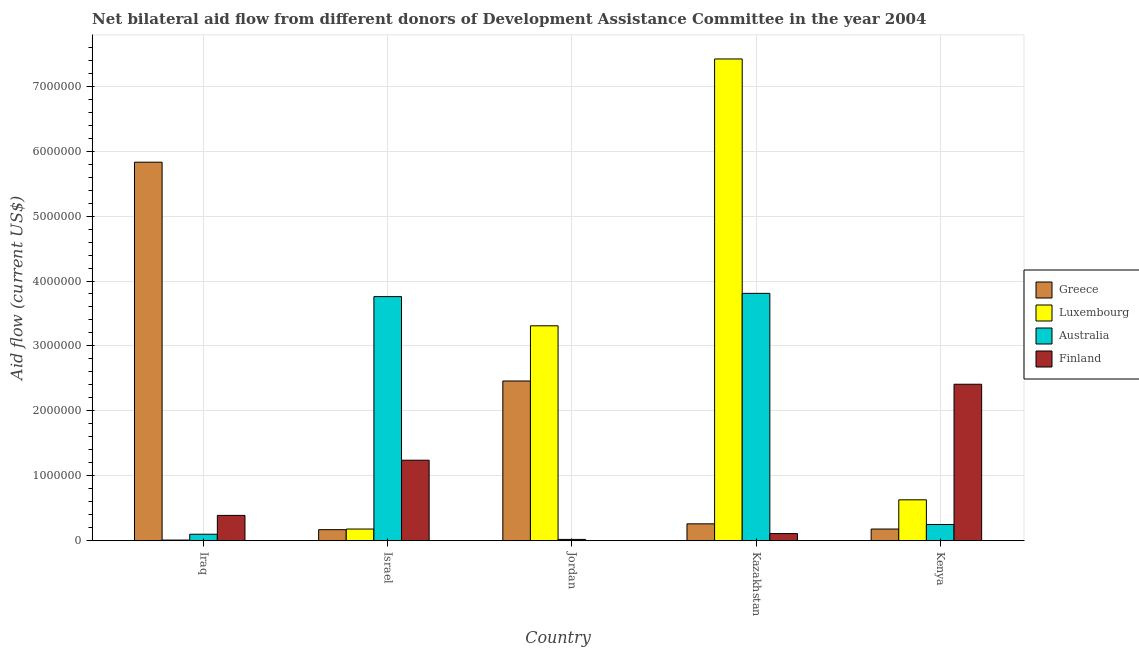How many different coloured bars are there?
Offer a terse response. 4. How many groups of bars are there?
Ensure brevity in your answer.  5. Are the number of bars per tick equal to the number of legend labels?
Your response must be concise. No. Are the number of bars on each tick of the X-axis equal?
Provide a succinct answer. No. What is the label of the 5th group of bars from the left?
Your answer should be compact. Kenya. In how many cases, is the number of bars for a given country not equal to the number of legend labels?
Your answer should be compact. 1. What is the amount of aid given by luxembourg in Kazakhstan?
Offer a terse response. 7.42e+06. Across all countries, what is the maximum amount of aid given by australia?
Offer a very short reply. 3.81e+06. Across all countries, what is the minimum amount of aid given by greece?
Provide a succinct answer. 1.70e+05. In which country was the amount of aid given by finland maximum?
Provide a short and direct response. Kenya. What is the total amount of aid given by greece in the graph?
Offer a very short reply. 8.90e+06. What is the difference between the amount of aid given by luxembourg in Israel and that in Kenya?
Make the answer very short. -4.50e+05. What is the difference between the amount of aid given by greece in Kenya and the amount of aid given by finland in Jordan?
Keep it short and to the point. 1.80e+05. What is the average amount of aid given by finland per country?
Give a very brief answer. 8.30e+05. What is the difference between the amount of aid given by finland and amount of aid given by greece in Israel?
Offer a very short reply. 1.07e+06. In how many countries, is the amount of aid given by finland greater than 7000000 US$?
Offer a very short reply. 0. What is the ratio of the amount of aid given by greece in Israel to that in Kazakhstan?
Your answer should be compact. 0.65. What is the difference between the highest and the second highest amount of aid given by luxembourg?
Your answer should be compact. 4.11e+06. What is the difference between the highest and the lowest amount of aid given by finland?
Your response must be concise. 2.41e+06. In how many countries, is the amount of aid given by greece greater than the average amount of aid given by greece taken over all countries?
Your answer should be compact. 2. Is it the case that in every country, the sum of the amount of aid given by greece and amount of aid given by australia is greater than the sum of amount of aid given by finland and amount of aid given by luxembourg?
Your answer should be compact. No. Is it the case that in every country, the sum of the amount of aid given by greece and amount of aid given by luxembourg is greater than the amount of aid given by australia?
Your response must be concise. No. How many bars are there?
Your answer should be compact. 19. What is the title of the graph?
Offer a terse response. Net bilateral aid flow from different donors of Development Assistance Committee in the year 2004. What is the label or title of the X-axis?
Provide a succinct answer. Country. What is the Aid flow (current US$) in Greece in Iraq?
Provide a succinct answer. 5.83e+06. What is the Aid flow (current US$) of Luxembourg in Iraq?
Offer a terse response. 10000. What is the Aid flow (current US$) of Australia in Iraq?
Your answer should be very brief. 1.00e+05. What is the Aid flow (current US$) in Greece in Israel?
Ensure brevity in your answer.  1.70e+05. What is the Aid flow (current US$) in Australia in Israel?
Your answer should be very brief. 3.76e+06. What is the Aid flow (current US$) of Finland in Israel?
Provide a short and direct response. 1.24e+06. What is the Aid flow (current US$) in Greece in Jordan?
Provide a short and direct response. 2.46e+06. What is the Aid flow (current US$) in Luxembourg in Jordan?
Make the answer very short. 3.31e+06. What is the Aid flow (current US$) of Australia in Jordan?
Keep it short and to the point. 2.00e+04. What is the Aid flow (current US$) in Luxembourg in Kazakhstan?
Offer a terse response. 7.42e+06. What is the Aid flow (current US$) of Australia in Kazakhstan?
Your answer should be very brief. 3.81e+06. What is the Aid flow (current US$) in Greece in Kenya?
Provide a succinct answer. 1.80e+05. What is the Aid flow (current US$) of Luxembourg in Kenya?
Provide a succinct answer. 6.30e+05. What is the Aid flow (current US$) in Australia in Kenya?
Make the answer very short. 2.50e+05. What is the Aid flow (current US$) in Finland in Kenya?
Your answer should be very brief. 2.41e+06. Across all countries, what is the maximum Aid flow (current US$) in Greece?
Your response must be concise. 5.83e+06. Across all countries, what is the maximum Aid flow (current US$) of Luxembourg?
Offer a very short reply. 7.42e+06. Across all countries, what is the maximum Aid flow (current US$) of Australia?
Provide a succinct answer. 3.81e+06. Across all countries, what is the maximum Aid flow (current US$) of Finland?
Your response must be concise. 2.41e+06. Across all countries, what is the minimum Aid flow (current US$) in Greece?
Your answer should be compact. 1.70e+05. Across all countries, what is the minimum Aid flow (current US$) in Luxembourg?
Provide a succinct answer. 10000. Across all countries, what is the minimum Aid flow (current US$) in Australia?
Offer a terse response. 2.00e+04. Across all countries, what is the minimum Aid flow (current US$) in Finland?
Provide a short and direct response. 0. What is the total Aid flow (current US$) of Greece in the graph?
Provide a short and direct response. 8.90e+06. What is the total Aid flow (current US$) in Luxembourg in the graph?
Your response must be concise. 1.16e+07. What is the total Aid flow (current US$) in Australia in the graph?
Offer a very short reply. 7.94e+06. What is the total Aid flow (current US$) in Finland in the graph?
Offer a terse response. 4.15e+06. What is the difference between the Aid flow (current US$) of Greece in Iraq and that in Israel?
Your answer should be compact. 5.66e+06. What is the difference between the Aid flow (current US$) in Australia in Iraq and that in Israel?
Provide a short and direct response. -3.66e+06. What is the difference between the Aid flow (current US$) of Finland in Iraq and that in Israel?
Give a very brief answer. -8.50e+05. What is the difference between the Aid flow (current US$) in Greece in Iraq and that in Jordan?
Keep it short and to the point. 3.37e+06. What is the difference between the Aid flow (current US$) of Luxembourg in Iraq and that in Jordan?
Give a very brief answer. -3.30e+06. What is the difference between the Aid flow (current US$) of Australia in Iraq and that in Jordan?
Offer a terse response. 8.00e+04. What is the difference between the Aid flow (current US$) in Greece in Iraq and that in Kazakhstan?
Your answer should be compact. 5.57e+06. What is the difference between the Aid flow (current US$) in Luxembourg in Iraq and that in Kazakhstan?
Your response must be concise. -7.41e+06. What is the difference between the Aid flow (current US$) of Australia in Iraq and that in Kazakhstan?
Offer a terse response. -3.71e+06. What is the difference between the Aid flow (current US$) of Finland in Iraq and that in Kazakhstan?
Provide a succinct answer. 2.80e+05. What is the difference between the Aid flow (current US$) in Greece in Iraq and that in Kenya?
Provide a short and direct response. 5.65e+06. What is the difference between the Aid flow (current US$) of Luxembourg in Iraq and that in Kenya?
Offer a very short reply. -6.20e+05. What is the difference between the Aid flow (current US$) in Finland in Iraq and that in Kenya?
Provide a succinct answer. -2.02e+06. What is the difference between the Aid flow (current US$) of Greece in Israel and that in Jordan?
Your response must be concise. -2.29e+06. What is the difference between the Aid flow (current US$) of Luxembourg in Israel and that in Jordan?
Make the answer very short. -3.13e+06. What is the difference between the Aid flow (current US$) of Australia in Israel and that in Jordan?
Make the answer very short. 3.74e+06. What is the difference between the Aid flow (current US$) of Greece in Israel and that in Kazakhstan?
Keep it short and to the point. -9.00e+04. What is the difference between the Aid flow (current US$) in Luxembourg in Israel and that in Kazakhstan?
Your answer should be very brief. -7.24e+06. What is the difference between the Aid flow (current US$) in Australia in Israel and that in Kazakhstan?
Keep it short and to the point. -5.00e+04. What is the difference between the Aid flow (current US$) of Finland in Israel and that in Kazakhstan?
Give a very brief answer. 1.13e+06. What is the difference between the Aid flow (current US$) in Luxembourg in Israel and that in Kenya?
Make the answer very short. -4.50e+05. What is the difference between the Aid flow (current US$) in Australia in Israel and that in Kenya?
Your answer should be compact. 3.51e+06. What is the difference between the Aid flow (current US$) in Finland in Israel and that in Kenya?
Provide a succinct answer. -1.17e+06. What is the difference between the Aid flow (current US$) of Greece in Jordan and that in Kazakhstan?
Your answer should be very brief. 2.20e+06. What is the difference between the Aid flow (current US$) of Luxembourg in Jordan and that in Kazakhstan?
Make the answer very short. -4.11e+06. What is the difference between the Aid flow (current US$) in Australia in Jordan and that in Kazakhstan?
Your answer should be compact. -3.79e+06. What is the difference between the Aid flow (current US$) of Greece in Jordan and that in Kenya?
Your response must be concise. 2.28e+06. What is the difference between the Aid flow (current US$) in Luxembourg in Jordan and that in Kenya?
Provide a short and direct response. 2.68e+06. What is the difference between the Aid flow (current US$) of Luxembourg in Kazakhstan and that in Kenya?
Provide a short and direct response. 6.79e+06. What is the difference between the Aid flow (current US$) in Australia in Kazakhstan and that in Kenya?
Keep it short and to the point. 3.56e+06. What is the difference between the Aid flow (current US$) of Finland in Kazakhstan and that in Kenya?
Provide a short and direct response. -2.30e+06. What is the difference between the Aid flow (current US$) of Greece in Iraq and the Aid flow (current US$) of Luxembourg in Israel?
Offer a terse response. 5.65e+06. What is the difference between the Aid flow (current US$) of Greece in Iraq and the Aid flow (current US$) of Australia in Israel?
Keep it short and to the point. 2.07e+06. What is the difference between the Aid flow (current US$) of Greece in Iraq and the Aid flow (current US$) of Finland in Israel?
Your response must be concise. 4.59e+06. What is the difference between the Aid flow (current US$) of Luxembourg in Iraq and the Aid flow (current US$) of Australia in Israel?
Ensure brevity in your answer.  -3.75e+06. What is the difference between the Aid flow (current US$) in Luxembourg in Iraq and the Aid flow (current US$) in Finland in Israel?
Make the answer very short. -1.23e+06. What is the difference between the Aid flow (current US$) in Australia in Iraq and the Aid flow (current US$) in Finland in Israel?
Your answer should be compact. -1.14e+06. What is the difference between the Aid flow (current US$) of Greece in Iraq and the Aid flow (current US$) of Luxembourg in Jordan?
Offer a terse response. 2.52e+06. What is the difference between the Aid flow (current US$) of Greece in Iraq and the Aid flow (current US$) of Australia in Jordan?
Your response must be concise. 5.81e+06. What is the difference between the Aid flow (current US$) in Greece in Iraq and the Aid flow (current US$) in Luxembourg in Kazakhstan?
Your answer should be very brief. -1.59e+06. What is the difference between the Aid flow (current US$) of Greece in Iraq and the Aid flow (current US$) of Australia in Kazakhstan?
Ensure brevity in your answer.  2.02e+06. What is the difference between the Aid flow (current US$) in Greece in Iraq and the Aid flow (current US$) in Finland in Kazakhstan?
Make the answer very short. 5.72e+06. What is the difference between the Aid flow (current US$) in Luxembourg in Iraq and the Aid flow (current US$) in Australia in Kazakhstan?
Offer a terse response. -3.80e+06. What is the difference between the Aid flow (current US$) in Luxembourg in Iraq and the Aid flow (current US$) in Finland in Kazakhstan?
Your answer should be very brief. -1.00e+05. What is the difference between the Aid flow (current US$) in Greece in Iraq and the Aid flow (current US$) in Luxembourg in Kenya?
Provide a succinct answer. 5.20e+06. What is the difference between the Aid flow (current US$) in Greece in Iraq and the Aid flow (current US$) in Australia in Kenya?
Offer a very short reply. 5.58e+06. What is the difference between the Aid flow (current US$) of Greece in Iraq and the Aid flow (current US$) of Finland in Kenya?
Give a very brief answer. 3.42e+06. What is the difference between the Aid flow (current US$) in Luxembourg in Iraq and the Aid flow (current US$) in Finland in Kenya?
Your response must be concise. -2.40e+06. What is the difference between the Aid flow (current US$) of Australia in Iraq and the Aid flow (current US$) of Finland in Kenya?
Keep it short and to the point. -2.31e+06. What is the difference between the Aid flow (current US$) of Greece in Israel and the Aid flow (current US$) of Luxembourg in Jordan?
Give a very brief answer. -3.14e+06. What is the difference between the Aid flow (current US$) in Luxembourg in Israel and the Aid flow (current US$) in Australia in Jordan?
Your answer should be compact. 1.60e+05. What is the difference between the Aid flow (current US$) in Greece in Israel and the Aid flow (current US$) in Luxembourg in Kazakhstan?
Keep it short and to the point. -7.25e+06. What is the difference between the Aid flow (current US$) in Greece in Israel and the Aid flow (current US$) in Australia in Kazakhstan?
Your answer should be very brief. -3.64e+06. What is the difference between the Aid flow (current US$) of Luxembourg in Israel and the Aid flow (current US$) of Australia in Kazakhstan?
Offer a terse response. -3.63e+06. What is the difference between the Aid flow (current US$) of Luxembourg in Israel and the Aid flow (current US$) of Finland in Kazakhstan?
Your answer should be very brief. 7.00e+04. What is the difference between the Aid flow (current US$) in Australia in Israel and the Aid flow (current US$) in Finland in Kazakhstan?
Ensure brevity in your answer.  3.65e+06. What is the difference between the Aid flow (current US$) of Greece in Israel and the Aid flow (current US$) of Luxembourg in Kenya?
Ensure brevity in your answer.  -4.60e+05. What is the difference between the Aid flow (current US$) in Greece in Israel and the Aid flow (current US$) in Australia in Kenya?
Make the answer very short. -8.00e+04. What is the difference between the Aid flow (current US$) of Greece in Israel and the Aid flow (current US$) of Finland in Kenya?
Make the answer very short. -2.24e+06. What is the difference between the Aid flow (current US$) of Luxembourg in Israel and the Aid flow (current US$) of Australia in Kenya?
Ensure brevity in your answer.  -7.00e+04. What is the difference between the Aid flow (current US$) in Luxembourg in Israel and the Aid flow (current US$) in Finland in Kenya?
Offer a very short reply. -2.23e+06. What is the difference between the Aid flow (current US$) in Australia in Israel and the Aid flow (current US$) in Finland in Kenya?
Your response must be concise. 1.35e+06. What is the difference between the Aid flow (current US$) of Greece in Jordan and the Aid flow (current US$) of Luxembourg in Kazakhstan?
Offer a very short reply. -4.96e+06. What is the difference between the Aid flow (current US$) of Greece in Jordan and the Aid flow (current US$) of Australia in Kazakhstan?
Offer a very short reply. -1.35e+06. What is the difference between the Aid flow (current US$) in Greece in Jordan and the Aid flow (current US$) in Finland in Kazakhstan?
Provide a short and direct response. 2.35e+06. What is the difference between the Aid flow (current US$) in Luxembourg in Jordan and the Aid flow (current US$) in Australia in Kazakhstan?
Offer a terse response. -5.00e+05. What is the difference between the Aid flow (current US$) in Luxembourg in Jordan and the Aid flow (current US$) in Finland in Kazakhstan?
Give a very brief answer. 3.20e+06. What is the difference between the Aid flow (current US$) of Greece in Jordan and the Aid flow (current US$) of Luxembourg in Kenya?
Your answer should be very brief. 1.83e+06. What is the difference between the Aid flow (current US$) of Greece in Jordan and the Aid flow (current US$) of Australia in Kenya?
Ensure brevity in your answer.  2.21e+06. What is the difference between the Aid flow (current US$) of Greece in Jordan and the Aid flow (current US$) of Finland in Kenya?
Offer a very short reply. 5.00e+04. What is the difference between the Aid flow (current US$) in Luxembourg in Jordan and the Aid flow (current US$) in Australia in Kenya?
Offer a terse response. 3.06e+06. What is the difference between the Aid flow (current US$) of Australia in Jordan and the Aid flow (current US$) of Finland in Kenya?
Your answer should be very brief. -2.39e+06. What is the difference between the Aid flow (current US$) in Greece in Kazakhstan and the Aid flow (current US$) in Luxembourg in Kenya?
Your response must be concise. -3.70e+05. What is the difference between the Aid flow (current US$) in Greece in Kazakhstan and the Aid flow (current US$) in Finland in Kenya?
Your answer should be compact. -2.15e+06. What is the difference between the Aid flow (current US$) of Luxembourg in Kazakhstan and the Aid flow (current US$) of Australia in Kenya?
Your answer should be compact. 7.17e+06. What is the difference between the Aid flow (current US$) of Luxembourg in Kazakhstan and the Aid flow (current US$) of Finland in Kenya?
Offer a very short reply. 5.01e+06. What is the difference between the Aid flow (current US$) of Australia in Kazakhstan and the Aid flow (current US$) of Finland in Kenya?
Give a very brief answer. 1.40e+06. What is the average Aid flow (current US$) of Greece per country?
Your answer should be very brief. 1.78e+06. What is the average Aid flow (current US$) of Luxembourg per country?
Offer a very short reply. 2.31e+06. What is the average Aid flow (current US$) in Australia per country?
Offer a very short reply. 1.59e+06. What is the average Aid flow (current US$) of Finland per country?
Provide a succinct answer. 8.30e+05. What is the difference between the Aid flow (current US$) of Greece and Aid flow (current US$) of Luxembourg in Iraq?
Provide a short and direct response. 5.82e+06. What is the difference between the Aid flow (current US$) in Greece and Aid flow (current US$) in Australia in Iraq?
Your answer should be compact. 5.73e+06. What is the difference between the Aid flow (current US$) of Greece and Aid flow (current US$) of Finland in Iraq?
Give a very brief answer. 5.44e+06. What is the difference between the Aid flow (current US$) in Luxembourg and Aid flow (current US$) in Australia in Iraq?
Your answer should be very brief. -9.00e+04. What is the difference between the Aid flow (current US$) in Luxembourg and Aid flow (current US$) in Finland in Iraq?
Your response must be concise. -3.80e+05. What is the difference between the Aid flow (current US$) of Australia and Aid flow (current US$) of Finland in Iraq?
Ensure brevity in your answer.  -2.90e+05. What is the difference between the Aid flow (current US$) of Greece and Aid flow (current US$) of Australia in Israel?
Provide a succinct answer. -3.59e+06. What is the difference between the Aid flow (current US$) in Greece and Aid flow (current US$) in Finland in Israel?
Your response must be concise. -1.07e+06. What is the difference between the Aid flow (current US$) of Luxembourg and Aid flow (current US$) of Australia in Israel?
Ensure brevity in your answer.  -3.58e+06. What is the difference between the Aid flow (current US$) of Luxembourg and Aid flow (current US$) of Finland in Israel?
Give a very brief answer. -1.06e+06. What is the difference between the Aid flow (current US$) in Australia and Aid flow (current US$) in Finland in Israel?
Make the answer very short. 2.52e+06. What is the difference between the Aid flow (current US$) of Greece and Aid flow (current US$) of Luxembourg in Jordan?
Your response must be concise. -8.50e+05. What is the difference between the Aid flow (current US$) in Greece and Aid flow (current US$) in Australia in Jordan?
Make the answer very short. 2.44e+06. What is the difference between the Aid flow (current US$) of Luxembourg and Aid flow (current US$) of Australia in Jordan?
Give a very brief answer. 3.29e+06. What is the difference between the Aid flow (current US$) in Greece and Aid flow (current US$) in Luxembourg in Kazakhstan?
Your answer should be very brief. -7.16e+06. What is the difference between the Aid flow (current US$) in Greece and Aid flow (current US$) in Australia in Kazakhstan?
Provide a short and direct response. -3.55e+06. What is the difference between the Aid flow (current US$) of Greece and Aid flow (current US$) of Finland in Kazakhstan?
Give a very brief answer. 1.50e+05. What is the difference between the Aid flow (current US$) in Luxembourg and Aid flow (current US$) in Australia in Kazakhstan?
Provide a short and direct response. 3.61e+06. What is the difference between the Aid flow (current US$) of Luxembourg and Aid flow (current US$) of Finland in Kazakhstan?
Provide a succinct answer. 7.31e+06. What is the difference between the Aid flow (current US$) of Australia and Aid flow (current US$) of Finland in Kazakhstan?
Give a very brief answer. 3.70e+06. What is the difference between the Aid flow (current US$) in Greece and Aid flow (current US$) in Luxembourg in Kenya?
Provide a succinct answer. -4.50e+05. What is the difference between the Aid flow (current US$) in Greece and Aid flow (current US$) in Finland in Kenya?
Your response must be concise. -2.23e+06. What is the difference between the Aid flow (current US$) of Luxembourg and Aid flow (current US$) of Australia in Kenya?
Your answer should be very brief. 3.80e+05. What is the difference between the Aid flow (current US$) of Luxembourg and Aid flow (current US$) of Finland in Kenya?
Provide a short and direct response. -1.78e+06. What is the difference between the Aid flow (current US$) of Australia and Aid flow (current US$) of Finland in Kenya?
Provide a short and direct response. -2.16e+06. What is the ratio of the Aid flow (current US$) of Greece in Iraq to that in Israel?
Your answer should be very brief. 34.29. What is the ratio of the Aid flow (current US$) in Luxembourg in Iraq to that in Israel?
Offer a very short reply. 0.06. What is the ratio of the Aid flow (current US$) in Australia in Iraq to that in Israel?
Offer a terse response. 0.03. What is the ratio of the Aid flow (current US$) of Finland in Iraq to that in Israel?
Offer a terse response. 0.31. What is the ratio of the Aid flow (current US$) in Greece in Iraq to that in Jordan?
Give a very brief answer. 2.37. What is the ratio of the Aid flow (current US$) of Luxembourg in Iraq to that in Jordan?
Make the answer very short. 0. What is the ratio of the Aid flow (current US$) in Greece in Iraq to that in Kazakhstan?
Ensure brevity in your answer.  22.42. What is the ratio of the Aid flow (current US$) in Luxembourg in Iraq to that in Kazakhstan?
Your answer should be very brief. 0. What is the ratio of the Aid flow (current US$) of Australia in Iraq to that in Kazakhstan?
Your answer should be compact. 0.03. What is the ratio of the Aid flow (current US$) in Finland in Iraq to that in Kazakhstan?
Ensure brevity in your answer.  3.55. What is the ratio of the Aid flow (current US$) of Greece in Iraq to that in Kenya?
Ensure brevity in your answer.  32.39. What is the ratio of the Aid flow (current US$) of Luxembourg in Iraq to that in Kenya?
Your answer should be very brief. 0.02. What is the ratio of the Aid flow (current US$) of Finland in Iraq to that in Kenya?
Offer a very short reply. 0.16. What is the ratio of the Aid flow (current US$) in Greece in Israel to that in Jordan?
Make the answer very short. 0.07. What is the ratio of the Aid flow (current US$) in Luxembourg in Israel to that in Jordan?
Your response must be concise. 0.05. What is the ratio of the Aid flow (current US$) in Australia in Israel to that in Jordan?
Keep it short and to the point. 188. What is the ratio of the Aid flow (current US$) in Greece in Israel to that in Kazakhstan?
Provide a succinct answer. 0.65. What is the ratio of the Aid flow (current US$) in Luxembourg in Israel to that in Kazakhstan?
Ensure brevity in your answer.  0.02. What is the ratio of the Aid flow (current US$) in Australia in Israel to that in Kazakhstan?
Offer a very short reply. 0.99. What is the ratio of the Aid flow (current US$) of Finland in Israel to that in Kazakhstan?
Your response must be concise. 11.27. What is the ratio of the Aid flow (current US$) of Greece in Israel to that in Kenya?
Your answer should be very brief. 0.94. What is the ratio of the Aid flow (current US$) in Luxembourg in Israel to that in Kenya?
Offer a very short reply. 0.29. What is the ratio of the Aid flow (current US$) of Australia in Israel to that in Kenya?
Keep it short and to the point. 15.04. What is the ratio of the Aid flow (current US$) in Finland in Israel to that in Kenya?
Provide a succinct answer. 0.51. What is the ratio of the Aid flow (current US$) of Greece in Jordan to that in Kazakhstan?
Provide a succinct answer. 9.46. What is the ratio of the Aid flow (current US$) in Luxembourg in Jordan to that in Kazakhstan?
Give a very brief answer. 0.45. What is the ratio of the Aid flow (current US$) in Australia in Jordan to that in Kazakhstan?
Offer a terse response. 0.01. What is the ratio of the Aid flow (current US$) in Greece in Jordan to that in Kenya?
Keep it short and to the point. 13.67. What is the ratio of the Aid flow (current US$) of Luxembourg in Jordan to that in Kenya?
Offer a very short reply. 5.25. What is the ratio of the Aid flow (current US$) in Greece in Kazakhstan to that in Kenya?
Provide a short and direct response. 1.44. What is the ratio of the Aid flow (current US$) of Luxembourg in Kazakhstan to that in Kenya?
Provide a short and direct response. 11.78. What is the ratio of the Aid flow (current US$) of Australia in Kazakhstan to that in Kenya?
Give a very brief answer. 15.24. What is the ratio of the Aid flow (current US$) of Finland in Kazakhstan to that in Kenya?
Your answer should be very brief. 0.05. What is the difference between the highest and the second highest Aid flow (current US$) in Greece?
Give a very brief answer. 3.37e+06. What is the difference between the highest and the second highest Aid flow (current US$) of Luxembourg?
Offer a terse response. 4.11e+06. What is the difference between the highest and the second highest Aid flow (current US$) of Finland?
Your answer should be very brief. 1.17e+06. What is the difference between the highest and the lowest Aid flow (current US$) of Greece?
Provide a succinct answer. 5.66e+06. What is the difference between the highest and the lowest Aid flow (current US$) of Luxembourg?
Make the answer very short. 7.41e+06. What is the difference between the highest and the lowest Aid flow (current US$) of Australia?
Offer a terse response. 3.79e+06. What is the difference between the highest and the lowest Aid flow (current US$) of Finland?
Keep it short and to the point. 2.41e+06. 